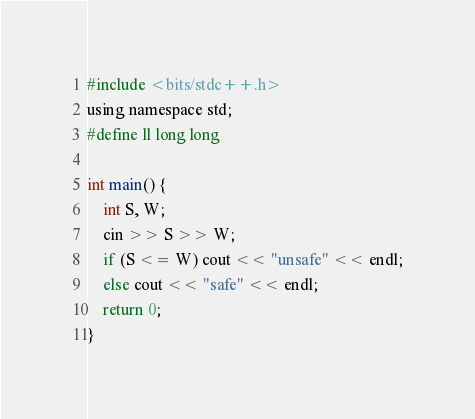<code> <loc_0><loc_0><loc_500><loc_500><_C_>#include <bits/stdc++.h>
using namespace std;
#define ll long long

int main() {
    int S, W;
    cin >> S >> W;
    if (S <= W) cout << "unsafe" << endl;
    else cout << "safe" << endl;
    return 0;
}
</code> 